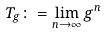<formula> <loc_0><loc_0><loc_500><loc_500>T _ { g } \colon = \lim _ { n \rightarrow \infty } g ^ { n }</formula> 